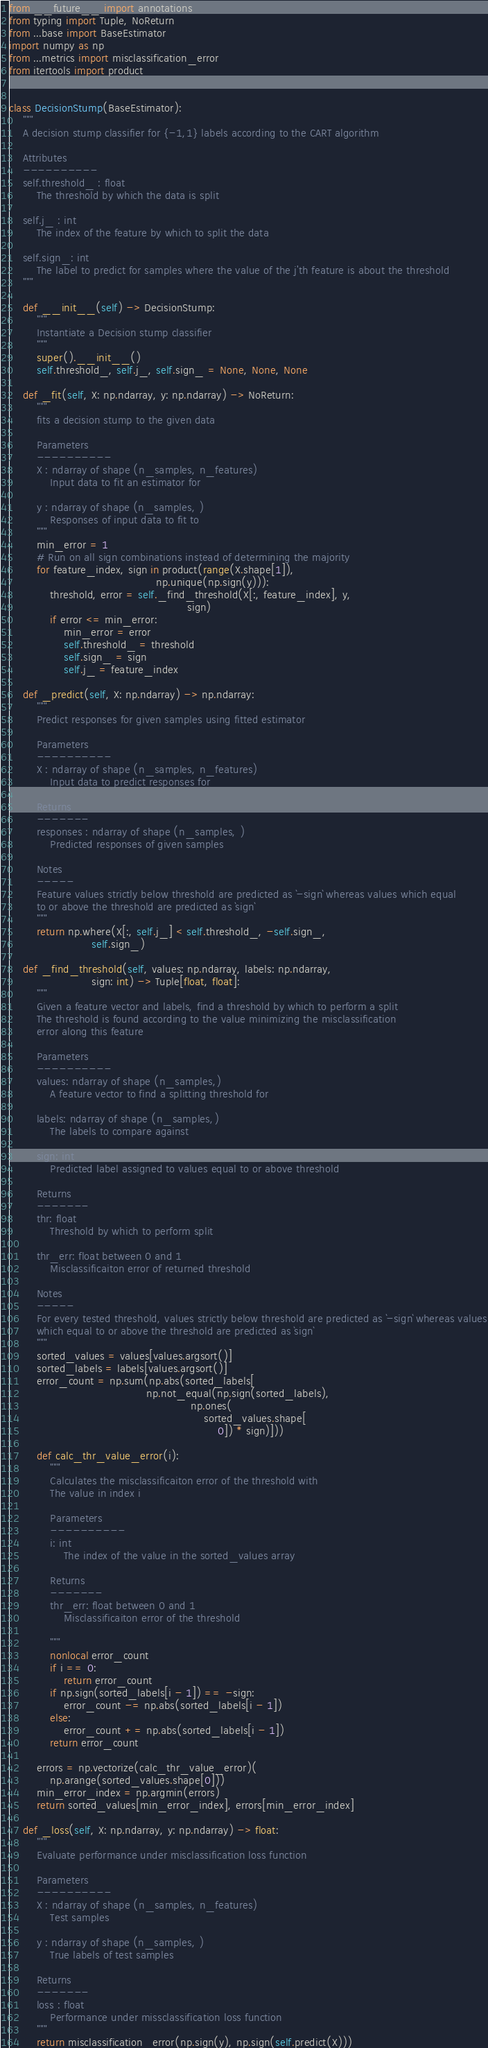<code> <loc_0><loc_0><loc_500><loc_500><_Python_>from __future__ import annotations
from typing import Tuple, NoReturn
from ...base import BaseEstimator
import numpy as np
from ...metrics import misclassification_error
from itertools import product


class DecisionStump(BaseEstimator):
    """
    A decision stump classifier for {-1,1} labels according to the CART algorithm

    Attributes
    ----------
    self.threshold_ : float
        The threshold by which the data is split

    self.j_ : int
        The index of the feature by which to split the data

    self.sign_: int
        The label to predict for samples where the value of the j'th feature is about the threshold
    """

    def __init__(self) -> DecisionStump:
        """
        Instantiate a Decision stump classifier
        """
        super().__init__()
        self.threshold_, self.j_, self.sign_ = None, None, None

    def _fit(self, X: np.ndarray, y: np.ndarray) -> NoReturn:
        """
        fits a decision stump to the given data

        Parameters
        ----------
        X : ndarray of shape (n_samples, n_features)
            Input data to fit an estimator for

        y : ndarray of shape (n_samples, )
            Responses of input data to fit to
        """
        min_error = 1
        # Run on all sign combinations instead of determining the majority
        for feature_index, sign in product(range(X.shape[1]),
                                           np.unique(np.sign(y))):
            threshold, error = self._find_threshold(X[:, feature_index], y,
                                                    sign)
            if error <= min_error:
                min_error = error
                self.threshold_ = threshold
                self.sign_ = sign
                self.j_ = feature_index

    def _predict(self, X: np.ndarray) -> np.ndarray:
        """
        Predict responses for given samples using fitted estimator

        Parameters
        ----------
        X : ndarray of shape (n_samples, n_features)
            Input data to predict responses for

        Returns
        -------
        responses : ndarray of shape (n_samples, )
            Predicted responses of given samples

        Notes
        -----
        Feature values strictly below threshold are predicted as `-sign` whereas values which equal
        to or above the threshold are predicted as `sign`
        """
        return np.where(X[:, self.j_] < self.threshold_, -self.sign_,
                        self.sign_)

    def _find_threshold(self, values: np.ndarray, labels: np.ndarray,
                        sign: int) -> Tuple[float, float]:
        """
        Given a feature vector and labels, find a threshold by which to perform a split
        The threshold is found according to the value minimizing the misclassification
        error along this feature

        Parameters
        ----------
        values: ndarray of shape (n_samples,)
            A feature vector to find a splitting threshold for

        labels: ndarray of shape (n_samples,)
            The labels to compare against

        sign: int
            Predicted label assigned to values equal to or above threshold

        Returns
        -------
        thr: float
            Threshold by which to perform split

        thr_err: float between 0 and 1
            Misclassificaiton error of returned threshold

        Notes
        -----
        For every tested threshold, values strictly below threshold are predicted as `-sign` whereas values
        which equal to or above the threshold are predicted as `sign`
        """
        sorted_values = values[values.argsort()]
        sorted_labels = labels[values.argsort()]
        error_count = np.sum(np.abs(sorted_labels[
                                        np.not_equal(np.sign(sorted_labels),
                                                     np.ones(
                                                         sorted_values.shape[
                                                             0]) * sign)]))

        def calc_thr_value_error(i):
            """
            Calculates the misclassificaiton error of the threshold with
            The value in index i

            Parameters
            ----------
            i: int
                The index of the value in the sorted_values array

            Returns
            -------
            thr_err: float between 0 and 1
                Misclassificaiton error of the threshold

            """
            nonlocal error_count
            if i == 0:
                return error_count
            if np.sign(sorted_labels[i - 1]) == -sign:
                error_count -= np.abs(sorted_labels[i - 1])
            else:
                error_count += np.abs(sorted_labels[i - 1])
            return error_count

        errors = np.vectorize(calc_thr_value_error)(
            np.arange(sorted_values.shape[0]))
        min_error_index = np.argmin(errors)
        return sorted_values[min_error_index], errors[min_error_index]

    def _loss(self, X: np.ndarray, y: np.ndarray) -> float:
        """
        Evaluate performance under misclassification loss function

        Parameters
        ----------
        X : ndarray of shape (n_samples, n_features)
            Test samples

        y : ndarray of shape (n_samples, )
            True labels of test samples

        Returns
        -------
        loss : float
            Performance under missclassification loss function
        """
        return misclassification_error(np.sign(y), np.sign(self.predict(X)))
</code> 